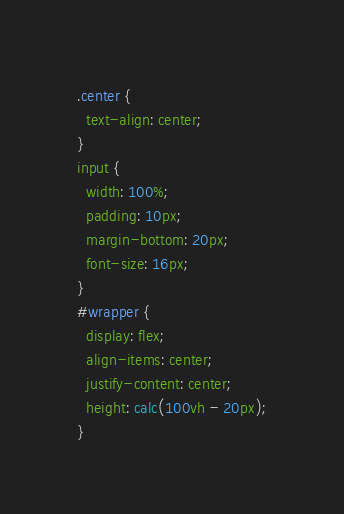<code> <loc_0><loc_0><loc_500><loc_500><_CSS_>.center {
  text-align: center;
}
input {
  width: 100%;
  padding: 10px;
  margin-bottom: 20px;
  font-size: 16px;
}
#wrapper {
  display: flex;
  align-items: center;
  justify-content: center;
  height: calc(100vh - 20px);
}</code> 